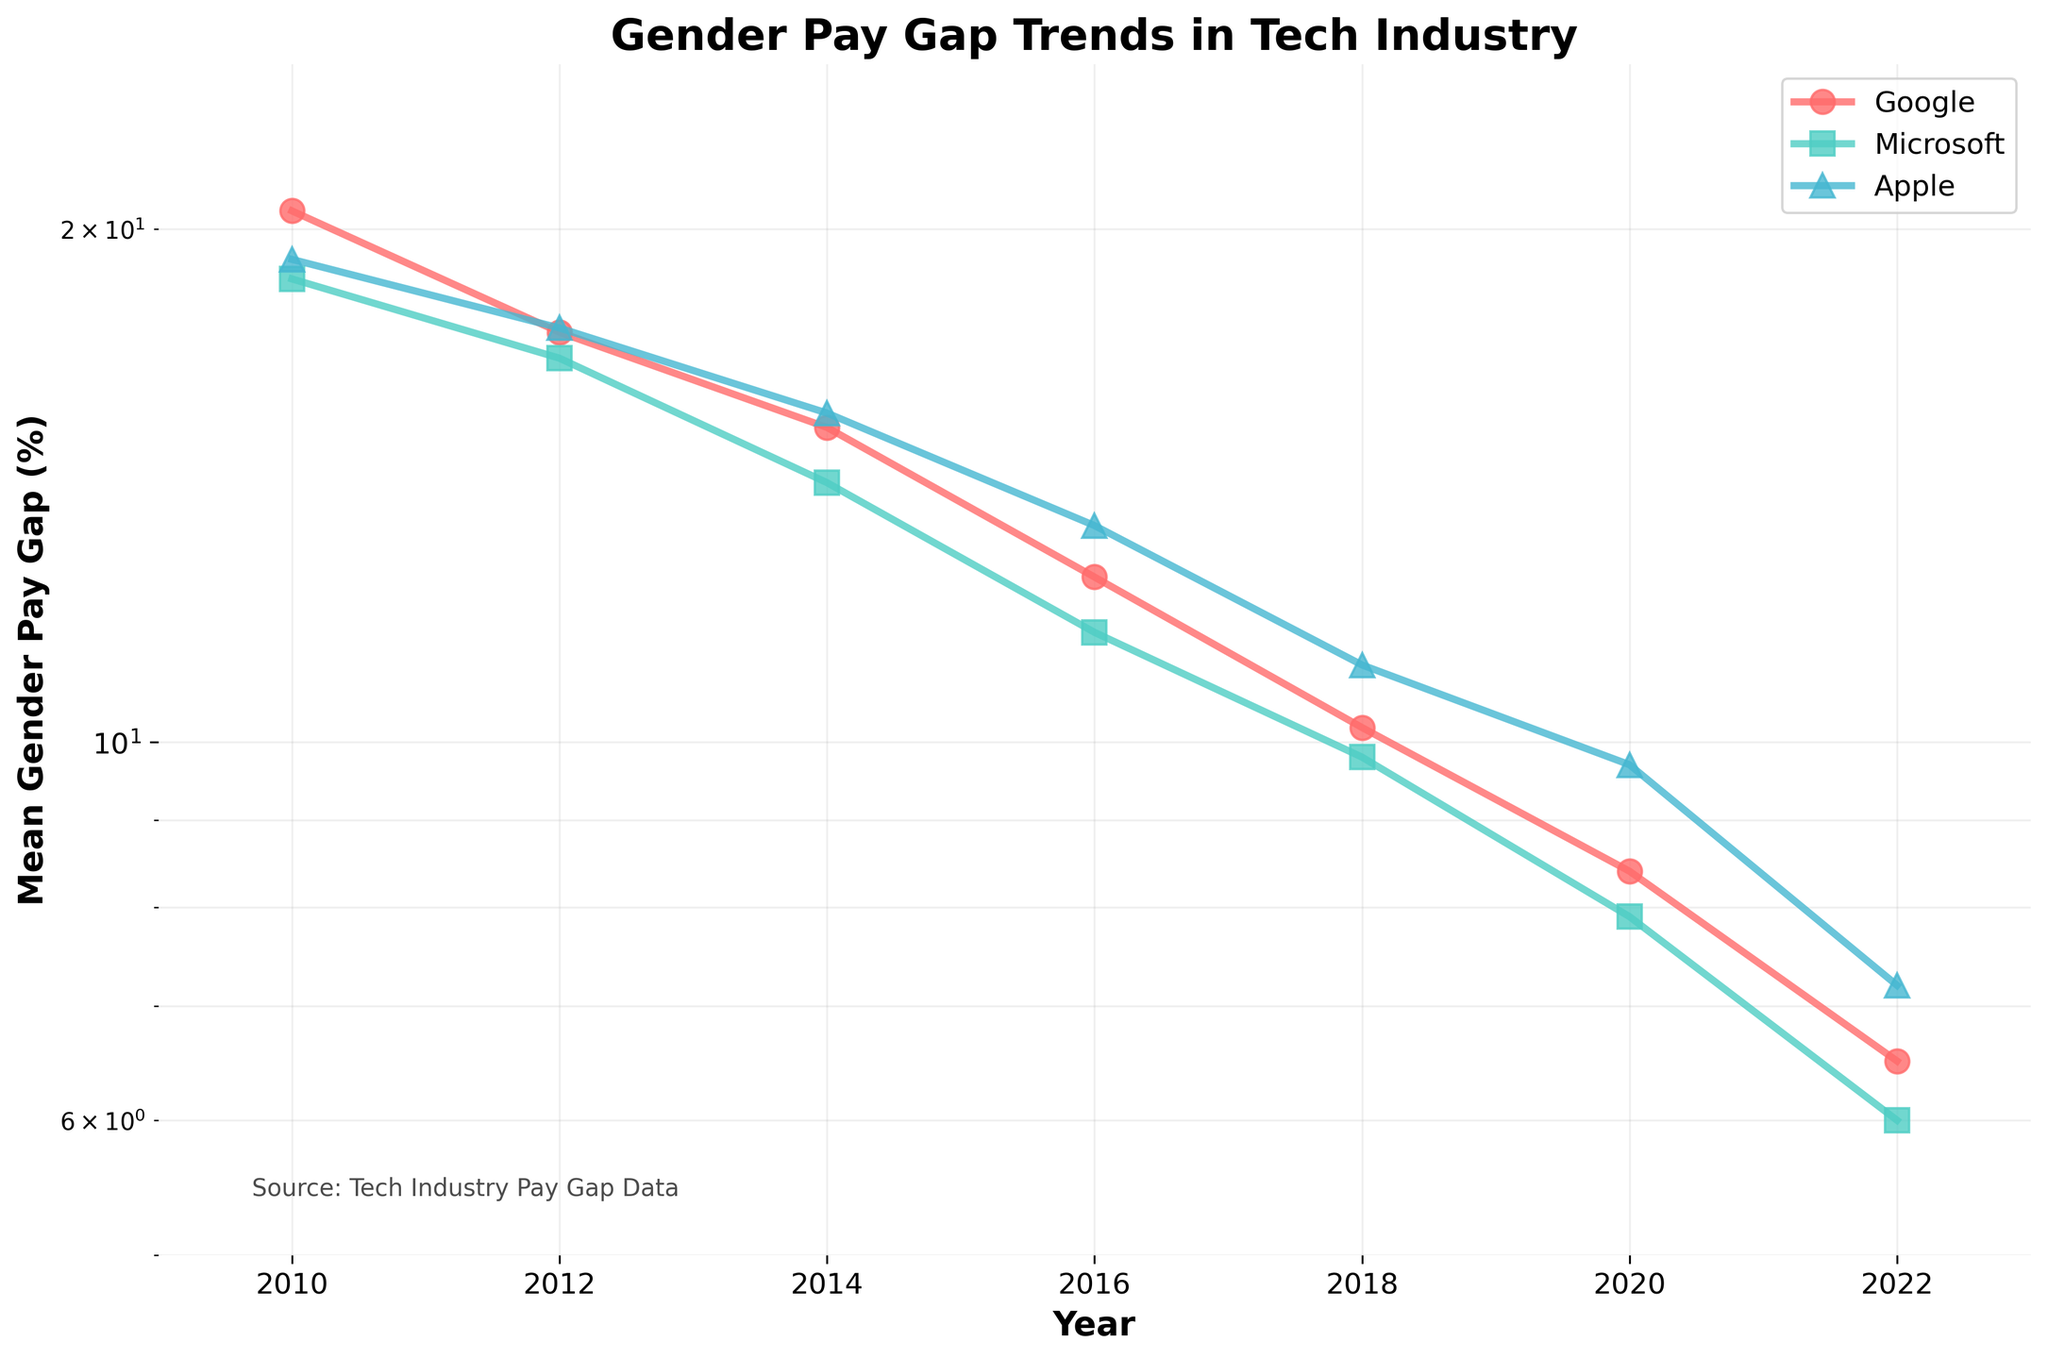what is the title of the figure? The title of the figure is typically located at the top and is bold and larger than other text elements in the figure. The title in this figure is "Gender Pay Gap Trends in Tech Industry".
Answer: Gender Pay Gap Trends in Tech Industry what colors are used to represent the companies? Different companies are represented by different colors in the figure. The colors used in this figure are red for Google, teal for Microsoft, and light blue for Apple.
Answer: Red for Google, Teal for Microsoft, Light blue for Apple how many years of data are displayed in the figure? The x-axis of the figure represents the years. By looking at the distinct tick marks along the x-axis, you can count the number of unique years presented.
Answer: 7 years (2010, 2012, 2014, 2016, 2018, 2020, 2022) which company shows the most significant decrease in the gender pay gap from 2010 to 2022? By looking at the starting (2010) and ending (2022) points for each company's line, we can compare the differences. Google starts at 20.5% and decreases to 6.5%, showing the most significant decrease.
Answer: Google in which year did all three companies have the closest mean gender pay gap percentages? By comparing the lines of the three companies, the year in which the lines are closest together horizontally can be identified. In 2018, the values are 10.2% (Google), 9.8% (Microsoft), and 11.1% (Apple), which are the closest.
Answer: 2018 what is the approximate average mean gender pay gap percentage for Apple across all years? The mean gender pay gap percentages for Apple across the years are 19.2, 17.5, 15.6, 13.4, 11.1, 9.7, and 7.2. Summing these values and dividing by the number of years (7) gives an approximate average. Calculation: (19.2 + 17.5 + 15.6 + 13.4 + 11.1 + 9.7 + 7.2) / 7 = approximately 13.52.
Answer: approximately 13.52 did any company achieve a mean gender pay gap percentage below 7% before 2020? By checking the y-values for each company before the year 2020, it is evident that no company had a mean gender pay gap percentage below 7% before 2020.
Answer: No what is the trend observed in gender pay gap percentages for Microsoft from 2010 to 2022? By examining the line representing Microsoft (teal color) from the start (2010) to the end (2022), it is evident that the gender pay gap percentage consistently decreases over the years.
Answer: Consistently decreases which company had a mean gender pay gap percentage closest to log scale axis in 2022? The log scale y values indicate smaller differences at lower values. In 2022, Microsoft had a mean gender pay gap percentage of 6.0%, which is closest to the lower end of the log scale.
Answer: Microsoft what is the source of the data used in the figure? The source of the data is mentioned as a text annotation within the figure. Near the bottom left, it states 'Source: Tech Industry Pay Gap Data'.
Answer: Tech Industry Pay Gap Data 